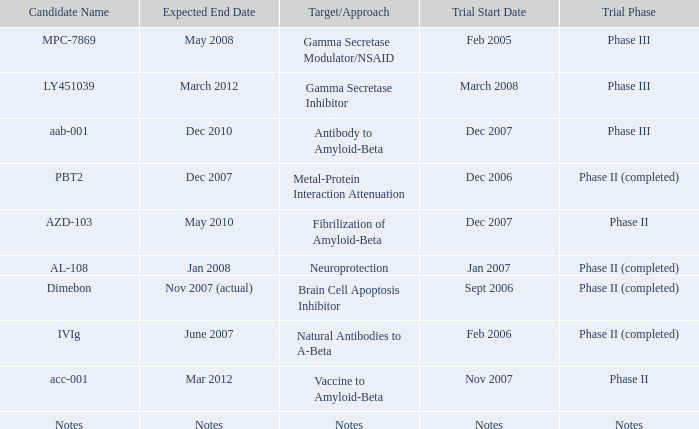What is Expected End Date, when Target/Approach is Notes? Notes. 